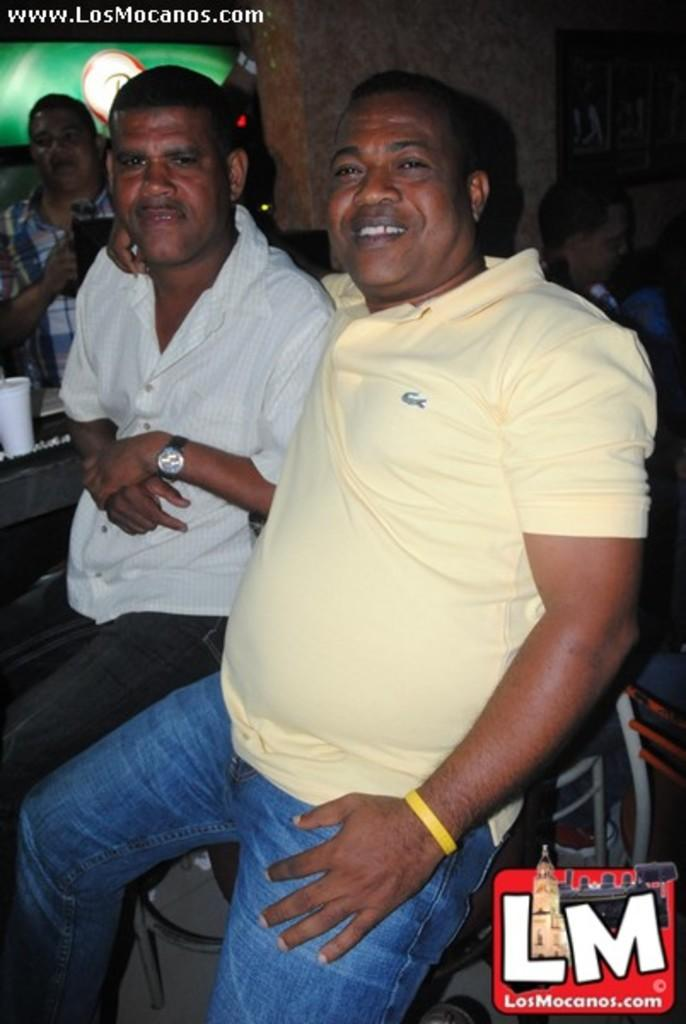How many people are in the image? There are four people in the image. What is the position of the first person in the image? The first person is standing. What is the position of the second person in the image? The second person is seated on a chair. How is the third person in the image positioned, and what is their facial expression? The third person is seated with a smile on their face. What is the position of the fourth person in the image? The fourth person is also seated. How many hats can be seen on the women in the image? There is no mention of hats or women in the image; it only describes the positions of four people. 